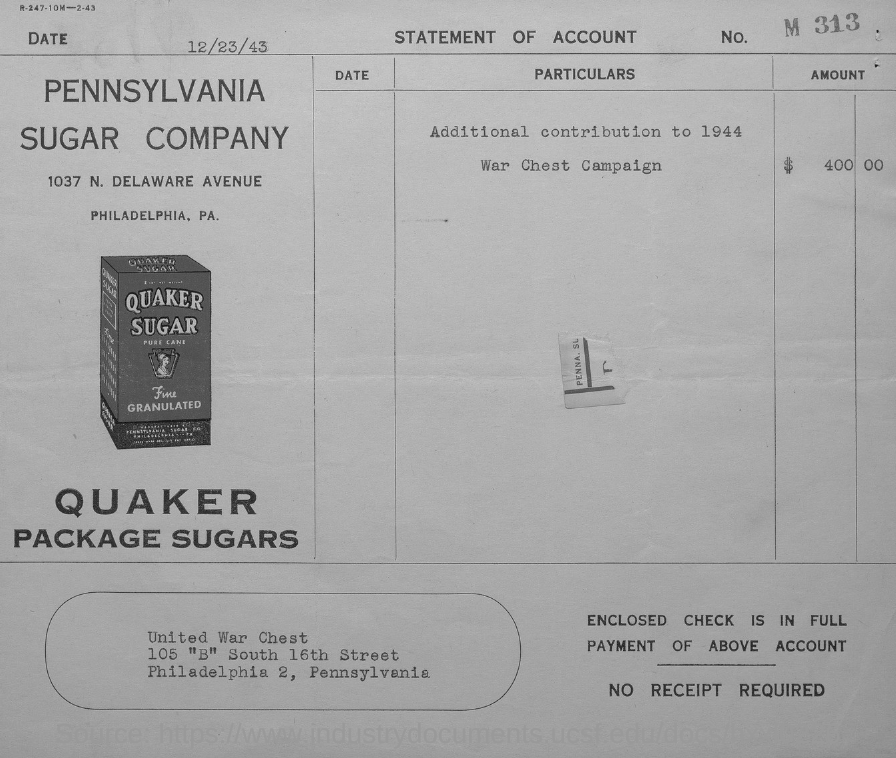What is the issued date of this statement?
Give a very brief answer. 12/23/43. What is the amount mentioned in the statement?
Your response must be concise. $   400 00. Which company's statement of account is this?
Make the answer very short. PENNSYLVANIA SUGAR COMPANY. What is the No. mentioned in the statement?
Make the answer very short. M 313. 